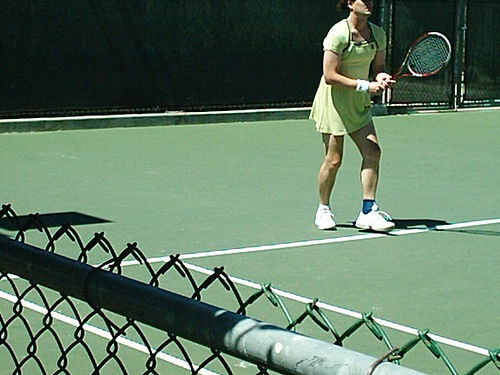Describe the objects in this image and their specific colors. I can see people in black, darkgreen, and beige tones and tennis racket in black, teal, and darkgreen tones in this image. 